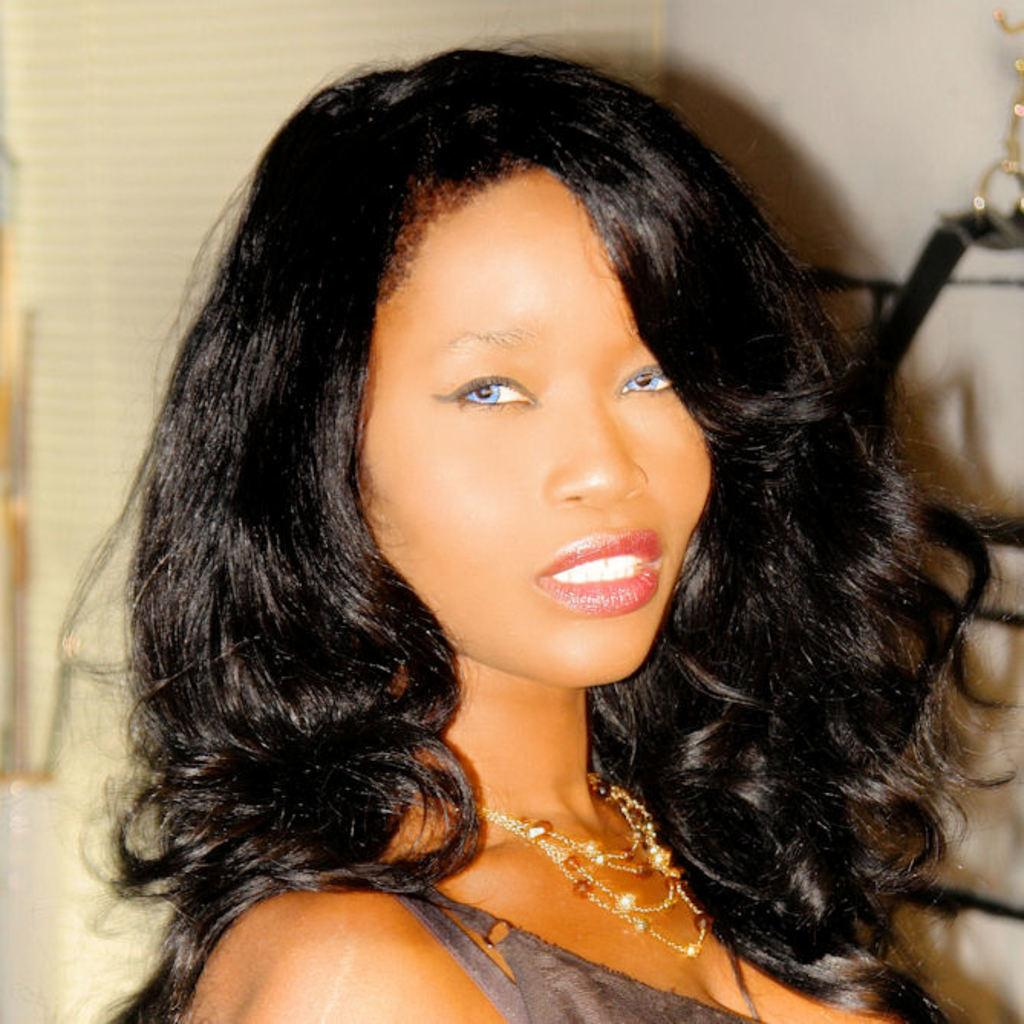Who is the main subject in the image? There is a woman in the image. Can you describe the woman's hair? The woman has black curly hair. What is the woman's facial expression in the image? The woman is smiling. What is the woman doing in the image? The woman is giving a pose into the camera. What type of gun is the woman holding in the image? There is no gun present in the image; the woman is not holding any object. 